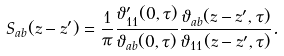<formula> <loc_0><loc_0><loc_500><loc_500>S _ { a b } ( z - z ^ { \prime } ) = \frac { 1 } { \pi } \frac { \vartheta _ { 1 1 } ^ { \prime } ( 0 , \tau ) } { \vartheta _ { a b } ( 0 , \tau ) } \frac { \vartheta _ { a b } ( z - z ^ { \prime } , \tau ) } { \vartheta _ { 1 1 } ( z - z ^ { \prime } , \tau ) } .</formula> 